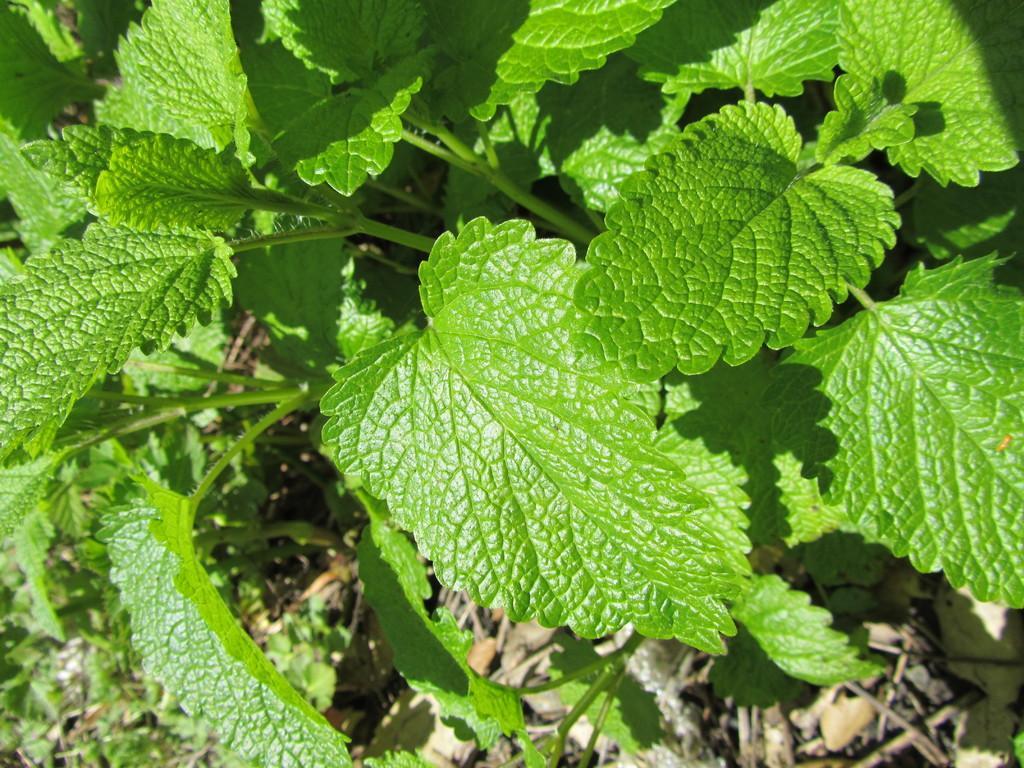Can you describe this image briefly? In this image there are mint leaves. 